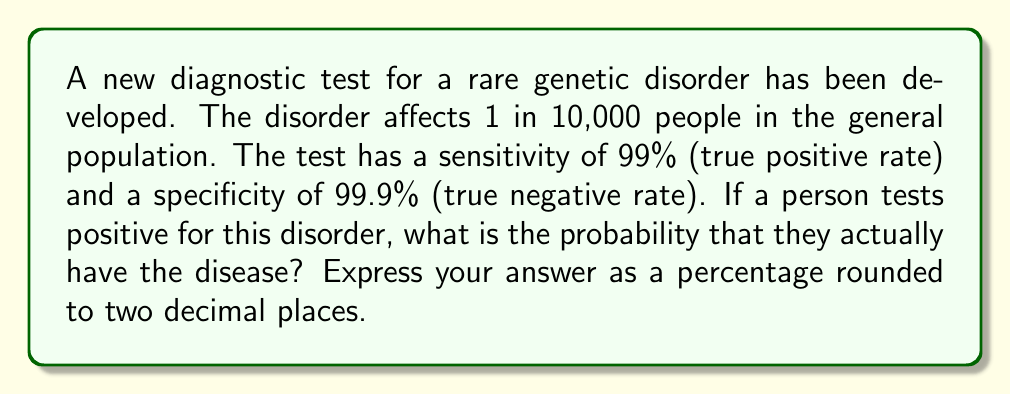Could you help me with this problem? To solve this problem, we'll use Bayes' theorem, which is particularly useful for updating probabilities based on new evidence. Let's define our events:

$D$: The person has the disease
$T$: The person tests positive

We want to find $P(D|T)$, the probability of having the disease given a positive test result.

Given:
- Prevalence: $P(D) = 1/10000 = 0.0001$
- Sensitivity: $P(T|D) = 0.99$
- Specificity: $P(T'|D') = 0.999$, where $T'$ and $D'$ are the complements of $T$ and $D$ respectively

Step 1: Calculate $P(T|D')$, the false positive rate:
$P(T|D') = 1 - P(T'|D') = 1 - 0.999 = 0.001$

Step 2: Apply Bayes' theorem:

$$P(D|T) = \frac{P(T|D) \cdot P(D)}{P(T|D) \cdot P(D) + P(T|D') \cdot P(D')}$$

Step 3: Calculate $P(D')$, the probability of not having the disease:
$P(D') = 1 - P(D) = 1 - 0.0001 = 0.9999$

Step 4: Substitute the values into Bayes' theorem:

$$P(D|T) = \frac{0.99 \cdot 0.0001}{0.99 \cdot 0.0001 + 0.001 \cdot 0.9999}$$

Step 5: Simplify and calculate:

$$P(D|T) = \frac{0.000099}{0.000099 + 0.0009999} = \frac{0.000099}{0.001098999} \approx 0.0900821$$

Step 6: Convert to a percentage and round to two decimal places:
$0.0900821 \cdot 100 \approx 9.01\%$
Answer: 9.01% 